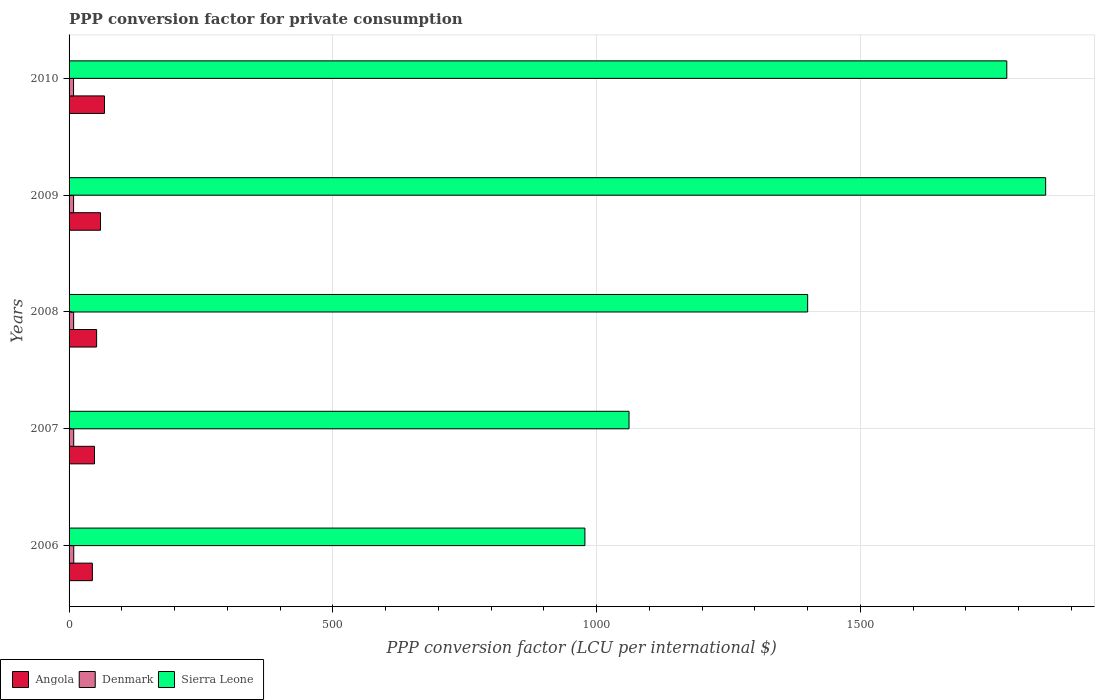How many different coloured bars are there?
Offer a terse response. 3. How many groups of bars are there?
Provide a short and direct response. 5. Are the number of bars per tick equal to the number of legend labels?
Make the answer very short. Yes. Are the number of bars on each tick of the Y-axis equal?
Provide a short and direct response. Yes. What is the label of the 5th group of bars from the top?
Offer a very short reply. 2006. What is the PPP conversion factor for private consumption in Sierra Leone in 2010?
Your answer should be compact. 1777.49. Across all years, what is the maximum PPP conversion factor for private consumption in Denmark?
Your response must be concise. 8.86. Across all years, what is the minimum PPP conversion factor for private consumption in Angola?
Make the answer very short. 44.17. In which year was the PPP conversion factor for private consumption in Angola maximum?
Ensure brevity in your answer.  2010. In which year was the PPP conversion factor for private consumption in Denmark minimum?
Ensure brevity in your answer.  2010. What is the total PPP conversion factor for private consumption in Denmark in the graph?
Your response must be concise. 43.33. What is the difference between the PPP conversion factor for private consumption in Sierra Leone in 2007 and that in 2008?
Provide a succinct answer. -338.6. What is the difference between the PPP conversion factor for private consumption in Sierra Leone in 2010 and the PPP conversion factor for private consumption in Denmark in 2008?
Your response must be concise. 1768.83. What is the average PPP conversion factor for private consumption in Angola per year?
Provide a succinct answer. 54.27. In the year 2010, what is the difference between the PPP conversion factor for private consumption in Sierra Leone and PPP conversion factor for private consumption in Denmark?
Keep it short and to the point. 1769. What is the ratio of the PPP conversion factor for private consumption in Denmark in 2008 to that in 2009?
Give a very brief answer. 1.01. Is the difference between the PPP conversion factor for private consumption in Sierra Leone in 2008 and 2009 greater than the difference between the PPP conversion factor for private consumption in Denmark in 2008 and 2009?
Ensure brevity in your answer.  No. What is the difference between the highest and the second highest PPP conversion factor for private consumption in Denmark?
Offer a terse response. 0.07. What is the difference between the highest and the lowest PPP conversion factor for private consumption in Sierra Leone?
Make the answer very short. 873.38. Is the sum of the PPP conversion factor for private consumption in Sierra Leone in 2006 and 2010 greater than the maximum PPP conversion factor for private consumption in Angola across all years?
Offer a very short reply. Yes. What does the 1st bar from the top in 2006 represents?
Give a very brief answer. Sierra Leone. What does the 3rd bar from the bottom in 2009 represents?
Make the answer very short. Sierra Leone. How many years are there in the graph?
Give a very brief answer. 5. What is the difference between two consecutive major ticks on the X-axis?
Your answer should be very brief. 500. Are the values on the major ticks of X-axis written in scientific E-notation?
Provide a short and direct response. No. Does the graph contain grids?
Provide a short and direct response. Yes. What is the title of the graph?
Your response must be concise. PPP conversion factor for private consumption. Does "Japan" appear as one of the legend labels in the graph?
Provide a succinct answer. No. What is the label or title of the X-axis?
Offer a terse response. PPP conversion factor (LCU per international $). What is the PPP conversion factor (LCU per international $) of Angola in 2006?
Your answer should be very brief. 44.17. What is the PPP conversion factor (LCU per international $) in Denmark in 2006?
Your answer should be compact. 8.86. What is the PPP conversion factor (LCU per international $) of Sierra Leone in 2006?
Your answer should be compact. 977.77. What is the PPP conversion factor (LCU per international $) of Angola in 2007?
Your response must be concise. 48.21. What is the PPP conversion factor (LCU per international $) of Denmark in 2007?
Offer a terse response. 8.79. What is the PPP conversion factor (LCU per international $) in Sierra Leone in 2007?
Provide a short and direct response. 1061.41. What is the PPP conversion factor (LCU per international $) of Angola in 2008?
Provide a succinct answer. 52.22. What is the PPP conversion factor (LCU per international $) in Denmark in 2008?
Provide a succinct answer. 8.65. What is the PPP conversion factor (LCU per international $) in Sierra Leone in 2008?
Give a very brief answer. 1400.01. What is the PPP conversion factor (LCU per international $) in Angola in 2009?
Keep it short and to the point. 59.6. What is the PPP conversion factor (LCU per international $) of Denmark in 2009?
Make the answer very short. 8.54. What is the PPP conversion factor (LCU per international $) of Sierra Leone in 2009?
Your response must be concise. 1851.15. What is the PPP conversion factor (LCU per international $) of Angola in 2010?
Offer a terse response. 67.12. What is the PPP conversion factor (LCU per international $) of Denmark in 2010?
Provide a short and direct response. 8.49. What is the PPP conversion factor (LCU per international $) of Sierra Leone in 2010?
Offer a very short reply. 1777.49. Across all years, what is the maximum PPP conversion factor (LCU per international $) in Angola?
Offer a very short reply. 67.12. Across all years, what is the maximum PPP conversion factor (LCU per international $) in Denmark?
Provide a succinct answer. 8.86. Across all years, what is the maximum PPP conversion factor (LCU per international $) of Sierra Leone?
Give a very brief answer. 1851.15. Across all years, what is the minimum PPP conversion factor (LCU per international $) in Angola?
Offer a terse response. 44.17. Across all years, what is the minimum PPP conversion factor (LCU per international $) in Denmark?
Make the answer very short. 8.49. Across all years, what is the minimum PPP conversion factor (LCU per international $) in Sierra Leone?
Offer a very short reply. 977.77. What is the total PPP conversion factor (LCU per international $) in Angola in the graph?
Offer a terse response. 271.33. What is the total PPP conversion factor (LCU per international $) of Denmark in the graph?
Make the answer very short. 43.33. What is the total PPP conversion factor (LCU per international $) of Sierra Leone in the graph?
Give a very brief answer. 7067.83. What is the difference between the PPP conversion factor (LCU per international $) in Angola in 2006 and that in 2007?
Provide a short and direct response. -4.04. What is the difference between the PPP conversion factor (LCU per international $) in Denmark in 2006 and that in 2007?
Your answer should be very brief. 0.07. What is the difference between the PPP conversion factor (LCU per international $) in Sierra Leone in 2006 and that in 2007?
Make the answer very short. -83.63. What is the difference between the PPP conversion factor (LCU per international $) in Angola in 2006 and that in 2008?
Your response must be concise. -8.04. What is the difference between the PPP conversion factor (LCU per international $) in Denmark in 2006 and that in 2008?
Give a very brief answer. 0.21. What is the difference between the PPP conversion factor (LCU per international $) of Sierra Leone in 2006 and that in 2008?
Your answer should be compact. -422.23. What is the difference between the PPP conversion factor (LCU per international $) in Angola in 2006 and that in 2009?
Keep it short and to the point. -15.43. What is the difference between the PPP conversion factor (LCU per international $) in Denmark in 2006 and that in 2009?
Your answer should be compact. 0.32. What is the difference between the PPP conversion factor (LCU per international $) in Sierra Leone in 2006 and that in 2009?
Offer a very short reply. -873.38. What is the difference between the PPP conversion factor (LCU per international $) in Angola in 2006 and that in 2010?
Provide a short and direct response. -22.95. What is the difference between the PPP conversion factor (LCU per international $) of Denmark in 2006 and that in 2010?
Provide a succinct answer. 0.37. What is the difference between the PPP conversion factor (LCU per international $) of Sierra Leone in 2006 and that in 2010?
Your response must be concise. -799.71. What is the difference between the PPP conversion factor (LCU per international $) in Angola in 2007 and that in 2008?
Provide a succinct answer. -4.01. What is the difference between the PPP conversion factor (LCU per international $) in Denmark in 2007 and that in 2008?
Your answer should be compact. 0.14. What is the difference between the PPP conversion factor (LCU per international $) of Sierra Leone in 2007 and that in 2008?
Offer a very short reply. -338.6. What is the difference between the PPP conversion factor (LCU per international $) of Angola in 2007 and that in 2009?
Keep it short and to the point. -11.39. What is the difference between the PPP conversion factor (LCU per international $) in Denmark in 2007 and that in 2009?
Offer a terse response. 0.26. What is the difference between the PPP conversion factor (LCU per international $) of Sierra Leone in 2007 and that in 2009?
Make the answer very short. -789.74. What is the difference between the PPP conversion factor (LCU per international $) of Angola in 2007 and that in 2010?
Give a very brief answer. -18.91. What is the difference between the PPP conversion factor (LCU per international $) in Denmark in 2007 and that in 2010?
Give a very brief answer. 0.3. What is the difference between the PPP conversion factor (LCU per international $) of Sierra Leone in 2007 and that in 2010?
Ensure brevity in your answer.  -716.08. What is the difference between the PPP conversion factor (LCU per international $) of Angola in 2008 and that in 2009?
Your response must be concise. -7.38. What is the difference between the PPP conversion factor (LCU per international $) in Denmark in 2008 and that in 2009?
Provide a succinct answer. 0.12. What is the difference between the PPP conversion factor (LCU per international $) of Sierra Leone in 2008 and that in 2009?
Provide a short and direct response. -451.15. What is the difference between the PPP conversion factor (LCU per international $) of Angola in 2008 and that in 2010?
Your answer should be compact. -14.91. What is the difference between the PPP conversion factor (LCU per international $) in Denmark in 2008 and that in 2010?
Provide a succinct answer. 0.16. What is the difference between the PPP conversion factor (LCU per international $) of Sierra Leone in 2008 and that in 2010?
Keep it short and to the point. -377.48. What is the difference between the PPP conversion factor (LCU per international $) in Angola in 2009 and that in 2010?
Offer a terse response. -7.52. What is the difference between the PPP conversion factor (LCU per international $) in Denmark in 2009 and that in 2010?
Offer a very short reply. 0.05. What is the difference between the PPP conversion factor (LCU per international $) in Sierra Leone in 2009 and that in 2010?
Your answer should be very brief. 73.67. What is the difference between the PPP conversion factor (LCU per international $) of Angola in 2006 and the PPP conversion factor (LCU per international $) of Denmark in 2007?
Provide a succinct answer. 35.38. What is the difference between the PPP conversion factor (LCU per international $) of Angola in 2006 and the PPP conversion factor (LCU per international $) of Sierra Leone in 2007?
Your answer should be very brief. -1017.23. What is the difference between the PPP conversion factor (LCU per international $) in Denmark in 2006 and the PPP conversion factor (LCU per international $) in Sierra Leone in 2007?
Give a very brief answer. -1052.55. What is the difference between the PPP conversion factor (LCU per international $) of Angola in 2006 and the PPP conversion factor (LCU per international $) of Denmark in 2008?
Provide a short and direct response. 35.52. What is the difference between the PPP conversion factor (LCU per international $) of Angola in 2006 and the PPP conversion factor (LCU per international $) of Sierra Leone in 2008?
Your answer should be compact. -1355.83. What is the difference between the PPP conversion factor (LCU per international $) of Denmark in 2006 and the PPP conversion factor (LCU per international $) of Sierra Leone in 2008?
Your answer should be compact. -1391.15. What is the difference between the PPP conversion factor (LCU per international $) in Angola in 2006 and the PPP conversion factor (LCU per international $) in Denmark in 2009?
Ensure brevity in your answer.  35.64. What is the difference between the PPP conversion factor (LCU per international $) in Angola in 2006 and the PPP conversion factor (LCU per international $) in Sierra Leone in 2009?
Give a very brief answer. -1806.98. What is the difference between the PPP conversion factor (LCU per international $) of Denmark in 2006 and the PPP conversion factor (LCU per international $) of Sierra Leone in 2009?
Offer a terse response. -1842.29. What is the difference between the PPP conversion factor (LCU per international $) of Angola in 2006 and the PPP conversion factor (LCU per international $) of Denmark in 2010?
Give a very brief answer. 35.68. What is the difference between the PPP conversion factor (LCU per international $) in Angola in 2006 and the PPP conversion factor (LCU per international $) in Sierra Leone in 2010?
Your answer should be compact. -1733.31. What is the difference between the PPP conversion factor (LCU per international $) in Denmark in 2006 and the PPP conversion factor (LCU per international $) in Sierra Leone in 2010?
Offer a very short reply. -1768.63. What is the difference between the PPP conversion factor (LCU per international $) in Angola in 2007 and the PPP conversion factor (LCU per international $) in Denmark in 2008?
Ensure brevity in your answer.  39.56. What is the difference between the PPP conversion factor (LCU per international $) in Angola in 2007 and the PPP conversion factor (LCU per international $) in Sierra Leone in 2008?
Your response must be concise. -1351.8. What is the difference between the PPP conversion factor (LCU per international $) in Denmark in 2007 and the PPP conversion factor (LCU per international $) in Sierra Leone in 2008?
Offer a very short reply. -1391.21. What is the difference between the PPP conversion factor (LCU per international $) of Angola in 2007 and the PPP conversion factor (LCU per international $) of Denmark in 2009?
Offer a terse response. 39.67. What is the difference between the PPP conversion factor (LCU per international $) of Angola in 2007 and the PPP conversion factor (LCU per international $) of Sierra Leone in 2009?
Provide a short and direct response. -1802.94. What is the difference between the PPP conversion factor (LCU per international $) in Denmark in 2007 and the PPP conversion factor (LCU per international $) in Sierra Leone in 2009?
Offer a terse response. -1842.36. What is the difference between the PPP conversion factor (LCU per international $) of Angola in 2007 and the PPP conversion factor (LCU per international $) of Denmark in 2010?
Ensure brevity in your answer.  39.72. What is the difference between the PPP conversion factor (LCU per international $) in Angola in 2007 and the PPP conversion factor (LCU per international $) in Sierra Leone in 2010?
Provide a short and direct response. -1729.28. What is the difference between the PPP conversion factor (LCU per international $) in Denmark in 2007 and the PPP conversion factor (LCU per international $) in Sierra Leone in 2010?
Keep it short and to the point. -1768.69. What is the difference between the PPP conversion factor (LCU per international $) of Angola in 2008 and the PPP conversion factor (LCU per international $) of Denmark in 2009?
Provide a short and direct response. 43.68. What is the difference between the PPP conversion factor (LCU per international $) of Angola in 2008 and the PPP conversion factor (LCU per international $) of Sierra Leone in 2009?
Give a very brief answer. -1798.93. What is the difference between the PPP conversion factor (LCU per international $) of Denmark in 2008 and the PPP conversion factor (LCU per international $) of Sierra Leone in 2009?
Provide a succinct answer. -1842.5. What is the difference between the PPP conversion factor (LCU per international $) in Angola in 2008 and the PPP conversion factor (LCU per international $) in Denmark in 2010?
Give a very brief answer. 43.73. What is the difference between the PPP conversion factor (LCU per international $) in Angola in 2008 and the PPP conversion factor (LCU per international $) in Sierra Leone in 2010?
Make the answer very short. -1725.27. What is the difference between the PPP conversion factor (LCU per international $) of Denmark in 2008 and the PPP conversion factor (LCU per international $) of Sierra Leone in 2010?
Your answer should be compact. -1768.83. What is the difference between the PPP conversion factor (LCU per international $) of Angola in 2009 and the PPP conversion factor (LCU per international $) of Denmark in 2010?
Offer a very short reply. 51.11. What is the difference between the PPP conversion factor (LCU per international $) of Angola in 2009 and the PPP conversion factor (LCU per international $) of Sierra Leone in 2010?
Provide a succinct answer. -1717.89. What is the difference between the PPP conversion factor (LCU per international $) of Denmark in 2009 and the PPP conversion factor (LCU per international $) of Sierra Leone in 2010?
Your answer should be very brief. -1768.95. What is the average PPP conversion factor (LCU per international $) in Angola per year?
Your response must be concise. 54.27. What is the average PPP conversion factor (LCU per international $) in Denmark per year?
Offer a very short reply. 8.67. What is the average PPP conversion factor (LCU per international $) in Sierra Leone per year?
Your answer should be very brief. 1413.57. In the year 2006, what is the difference between the PPP conversion factor (LCU per international $) of Angola and PPP conversion factor (LCU per international $) of Denmark?
Provide a short and direct response. 35.31. In the year 2006, what is the difference between the PPP conversion factor (LCU per international $) of Angola and PPP conversion factor (LCU per international $) of Sierra Leone?
Your answer should be very brief. -933.6. In the year 2006, what is the difference between the PPP conversion factor (LCU per international $) of Denmark and PPP conversion factor (LCU per international $) of Sierra Leone?
Give a very brief answer. -968.91. In the year 2007, what is the difference between the PPP conversion factor (LCU per international $) in Angola and PPP conversion factor (LCU per international $) in Denmark?
Offer a very short reply. 39.42. In the year 2007, what is the difference between the PPP conversion factor (LCU per international $) of Angola and PPP conversion factor (LCU per international $) of Sierra Leone?
Offer a very short reply. -1013.2. In the year 2007, what is the difference between the PPP conversion factor (LCU per international $) of Denmark and PPP conversion factor (LCU per international $) of Sierra Leone?
Your answer should be compact. -1052.61. In the year 2008, what is the difference between the PPP conversion factor (LCU per international $) of Angola and PPP conversion factor (LCU per international $) of Denmark?
Your answer should be compact. 43.57. In the year 2008, what is the difference between the PPP conversion factor (LCU per international $) of Angola and PPP conversion factor (LCU per international $) of Sierra Leone?
Offer a terse response. -1347.79. In the year 2008, what is the difference between the PPP conversion factor (LCU per international $) in Denmark and PPP conversion factor (LCU per international $) in Sierra Leone?
Give a very brief answer. -1391.35. In the year 2009, what is the difference between the PPP conversion factor (LCU per international $) in Angola and PPP conversion factor (LCU per international $) in Denmark?
Your answer should be very brief. 51.06. In the year 2009, what is the difference between the PPP conversion factor (LCU per international $) of Angola and PPP conversion factor (LCU per international $) of Sierra Leone?
Keep it short and to the point. -1791.55. In the year 2009, what is the difference between the PPP conversion factor (LCU per international $) in Denmark and PPP conversion factor (LCU per international $) in Sierra Leone?
Offer a very short reply. -1842.62. In the year 2010, what is the difference between the PPP conversion factor (LCU per international $) of Angola and PPP conversion factor (LCU per international $) of Denmark?
Offer a terse response. 58.63. In the year 2010, what is the difference between the PPP conversion factor (LCU per international $) of Angola and PPP conversion factor (LCU per international $) of Sierra Leone?
Ensure brevity in your answer.  -1710.36. In the year 2010, what is the difference between the PPP conversion factor (LCU per international $) in Denmark and PPP conversion factor (LCU per international $) in Sierra Leone?
Your answer should be compact. -1769. What is the ratio of the PPP conversion factor (LCU per international $) of Angola in 2006 to that in 2007?
Provide a short and direct response. 0.92. What is the ratio of the PPP conversion factor (LCU per international $) of Denmark in 2006 to that in 2007?
Keep it short and to the point. 1.01. What is the ratio of the PPP conversion factor (LCU per international $) of Sierra Leone in 2006 to that in 2007?
Give a very brief answer. 0.92. What is the ratio of the PPP conversion factor (LCU per international $) in Angola in 2006 to that in 2008?
Keep it short and to the point. 0.85. What is the ratio of the PPP conversion factor (LCU per international $) of Denmark in 2006 to that in 2008?
Give a very brief answer. 1.02. What is the ratio of the PPP conversion factor (LCU per international $) of Sierra Leone in 2006 to that in 2008?
Your answer should be very brief. 0.7. What is the ratio of the PPP conversion factor (LCU per international $) of Angola in 2006 to that in 2009?
Give a very brief answer. 0.74. What is the ratio of the PPP conversion factor (LCU per international $) in Denmark in 2006 to that in 2009?
Provide a succinct answer. 1.04. What is the ratio of the PPP conversion factor (LCU per international $) in Sierra Leone in 2006 to that in 2009?
Provide a short and direct response. 0.53. What is the ratio of the PPP conversion factor (LCU per international $) of Angola in 2006 to that in 2010?
Ensure brevity in your answer.  0.66. What is the ratio of the PPP conversion factor (LCU per international $) of Denmark in 2006 to that in 2010?
Offer a terse response. 1.04. What is the ratio of the PPP conversion factor (LCU per international $) of Sierra Leone in 2006 to that in 2010?
Keep it short and to the point. 0.55. What is the ratio of the PPP conversion factor (LCU per international $) in Angola in 2007 to that in 2008?
Provide a succinct answer. 0.92. What is the ratio of the PPP conversion factor (LCU per international $) in Denmark in 2007 to that in 2008?
Your answer should be very brief. 1.02. What is the ratio of the PPP conversion factor (LCU per international $) of Sierra Leone in 2007 to that in 2008?
Your answer should be very brief. 0.76. What is the ratio of the PPP conversion factor (LCU per international $) of Angola in 2007 to that in 2009?
Provide a short and direct response. 0.81. What is the ratio of the PPP conversion factor (LCU per international $) of Denmark in 2007 to that in 2009?
Provide a short and direct response. 1.03. What is the ratio of the PPP conversion factor (LCU per international $) in Sierra Leone in 2007 to that in 2009?
Offer a very short reply. 0.57. What is the ratio of the PPP conversion factor (LCU per international $) in Angola in 2007 to that in 2010?
Ensure brevity in your answer.  0.72. What is the ratio of the PPP conversion factor (LCU per international $) of Denmark in 2007 to that in 2010?
Make the answer very short. 1.04. What is the ratio of the PPP conversion factor (LCU per international $) of Sierra Leone in 2007 to that in 2010?
Your answer should be very brief. 0.6. What is the ratio of the PPP conversion factor (LCU per international $) of Angola in 2008 to that in 2009?
Your answer should be compact. 0.88. What is the ratio of the PPP conversion factor (LCU per international $) of Denmark in 2008 to that in 2009?
Your response must be concise. 1.01. What is the ratio of the PPP conversion factor (LCU per international $) in Sierra Leone in 2008 to that in 2009?
Your response must be concise. 0.76. What is the ratio of the PPP conversion factor (LCU per international $) of Angola in 2008 to that in 2010?
Provide a short and direct response. 0.78. What is the ratio of the PPP conversion factor (LCU per international $) of Denmark in 2008 to that in 2010?
Your answer should be compact. 1.02. What is the ratio of the PPP conversion factor (LCU per international $) in Sierra Leone in 2008 to that in 2010?
Your answer should be very brief. 0.79. What is the ratio of the PPP conversion factor (LCU per international $) of Angola in 2009 to that in 2010?
Ensure brevity in your answer.  0.89. What is the ratio of the PPP conversion factor (LCU per international $) of Denmark in 2009 to that in 2010?
Give a very brief answer. 1.01. What is the ratio of the PPP conversion factor (LCU per international $) in Sierra Leone in 2009 to that in 2010?
Provide a short and direct response. 1.04. What is the difference between the highest and the second highest PPP conversion factor (LCU per international $) in Angola?
Provide a succinct answer. 7.52. What is the difference between the highest and the second highest PPP conversion factor (LCU per international $) in Denmark?
Make the answer very short. 0.07. What is the difference between the highest and the second highest PPP conversion factor (LCU per international $) in Sierra Leone?
Offer a very short reply. 73.67. What is the difference between the highest and the lowest PPP conversion factor (LCU per international $) in Angola?
Offer a terse response. 22.95. What is the difference between the highest and the lowest PPP conversion factor (LCU per international $) in Denmark?
Your answer should be very brief. 0.37. What is the difference between the highest and the lowest PPP conversion factor (LCU per international $) in Sierra Leone?
Give a very brief answer. 873.38. 